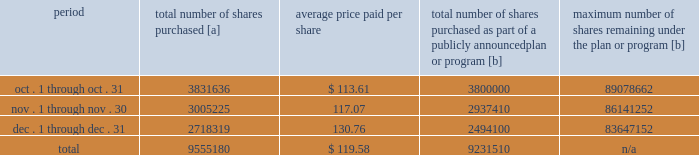Five-year performance comparison 2013 the following graph provides an indicator of cumulative total shareholder returns for the corporation as compared to the peer group index ( described above ) , the dj trans , and the s&p 500 .
The graph assumes that $ 100 was invested in the common stock of union pacific corporation and each index on december 31 , 2012 and that all dividends were reinvested .
The information below is historical in nature and is not necessarily indicative of future performance .
Purchases of equity securities 2013 during 2017 , we repurchased 37122405 shares of our common stock at an average price of $ 110.50 .
The table presents common stock repurchases during each month for the fourth quarter of 2017 : period total number of shares purchased [a] average price paid per share total number of shares purchased as part of a publicly announced plan or program [b] maximum number of shares remaining under the plan or program [b] .
[a] total number of shares purchased during the quarter includes approximately 323670 shares delivered or attested to upc by employees to pay stock option exercise prices , satisfy excess tax withholding obligations for stock option exercises or vesting of retention units , and pay withholding obligations for vesting of retention shares .
[b] effective january 1 , 2017 , our board of directors authorized the repurchase of up to 120 million shares of our common stock by december 31 , 2020 .
These repurchases may be made on the open market or through other transactions .
Our management has sole discretion with respect to determining the timing and amount of these transactions. .
For the fourth quarter of 2017 what was the percent of the total number of shares purchased in october? 
Computations: (3831636 / 9555180)
Answer: 0.401. 